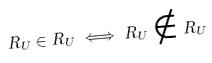Convert formula to latex. <formula><loc_0><loc_0><loc_500><loc_500>R _ { U } \in R _ { U } \iff R _ { U } \notin R _ { U }</formula> 